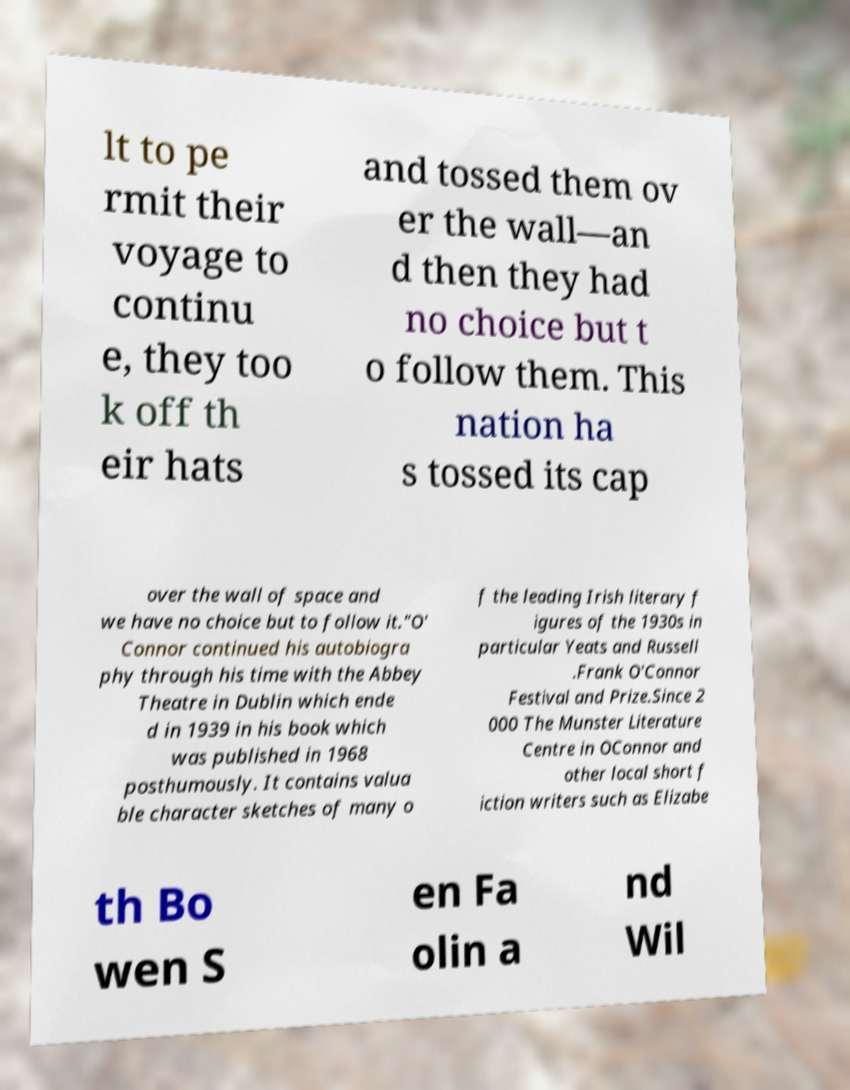Could you assist in decoding the text presented in this image and type it out clearly? lt to pe rmit their voyage to continu e, they too k off th eir hats and tossed them ov er the wall—an d then they had no choice but t o follow them. This nation ha s tossed its cap over the wall of space and we have no choice but to follow it."O' Connor continued his autobiogra phy through his time with the Abbey Theatre in Dublin which ende d in 1939 in his book which was published in 1968 posthumously. It contains valua ble character sketches of many o f the leading Irish literary f igures of the 1930s in particular Yeats and Russell .Frank O'Connor Festival and Prize.Since 2 000 The Munster Literature Centre in OConnor and other local short f iction writers such as Elizabe th Bo wen S en Fa olin a nd Wil 